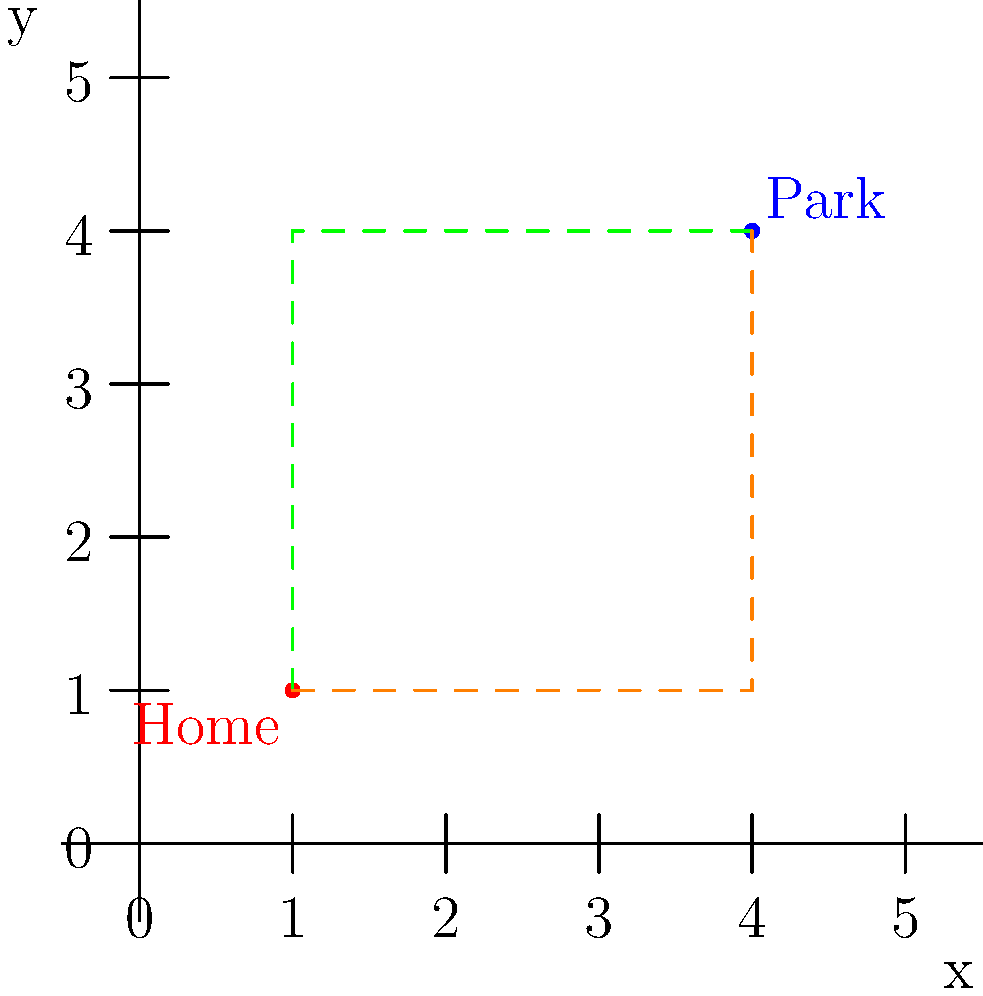You're planning a walk for your dog who has been responding well to new medication. Your home is at coordinates (1,1) and the dog park is at (4,4) on a grid map of your neighborhood. You can only walk along the grid lines. If you want to take your dog on the longest possible route to the park, how many blocks will you walk? To solve this problem, we'll follow these steps:

1) First, let's understand what the question is asking:
   - We start at (1,1) and need to reach (4,4)
   - We can only move along the grid lines
   - We want the longest possible route

2) The longest route will involve going to the farthest corner before turning towards the park.

3) There are two possible longest routes:
   a) Go right first: (1,1) → (4,1) → (4,4)
   b) Go up first: (1,1) → (1,4) → (4,4)

4) Let's calculate the distance for either route:
   - Horizontal distance: 4 - 1 = 3 blocks
   - Vertical distance: 4 - 1 = 3 blocks
   - Total distance: 3 + 3 = 6 blocks

5) Both routes (right first or up first) will result in the same distance of 6 blocks.

Therefore, the longest possible route to walk your dog to the park is 6 blocks.
Answer: 6 blocks 